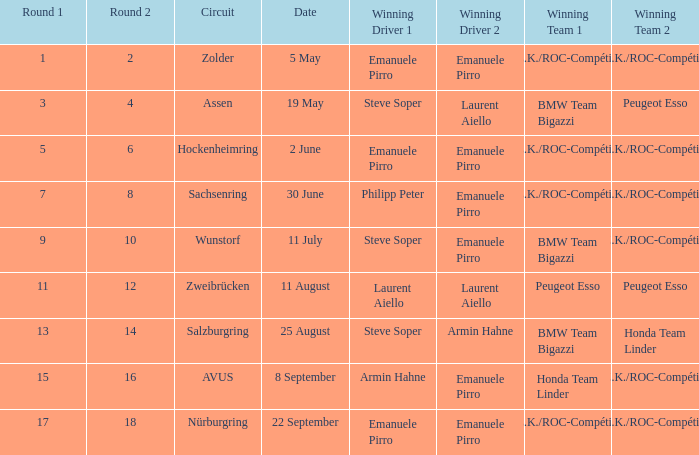On the 11th of july, which team came out on top? BMW Team Bigazzi A.Z.K./ROC-Compétition. 